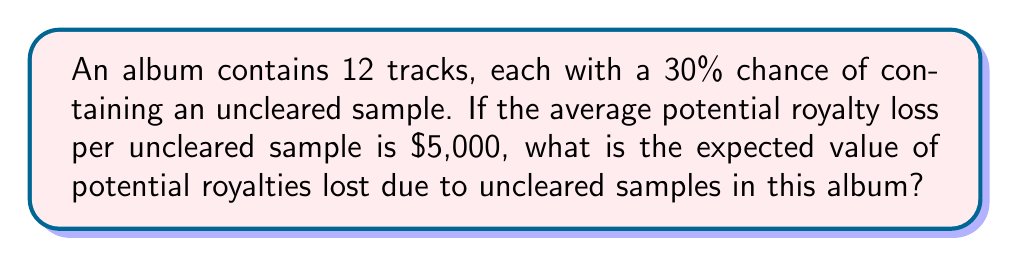Give your solution to this math problem. To solve this problem, we'll follow these steps:

1) First, we need to calculate the expected number of tracks with uncleared samples.
   Let $X$ be the number of tracks with uncleared samples.
   $X$ follows a binomial distribution with $n=12$ and $p=0.3$
   The expected value of $X$ is:
   
   $$E(X) = np = 12 * 0.3 = 3.6$$

2) Now, we know that each uncleared sample results in an average potential royalty loss of $5,000.
   Let $Y$ be the total potential royalty loss.
   
   $$Y = 5000X$$

3) The expected value of $Y$ is:

   $$E(Y) = E(5000X) = 5000E(X)$$

4) Substituting the value we calculated for $E(X)$:

   $$E(Y) = 5000 * 3.6 = 18,000$$

Therefore, the expected value of potential royalties lost due to uncleared samples in this album is $18,000.
Answer: $18,000 